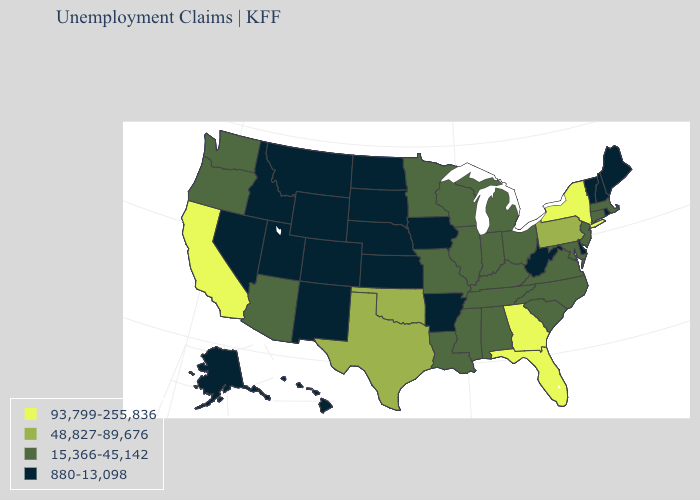What is the value of Virginia?
Give a very brief answer. 15,366-45,142. What is the highest value in states that border Arizona?
Give a very brief answer. 93,799-255,836. Which states have the lowest value in the Northeast?
Keep it brief. Maine, New Hampshire, Rhode Island, Vermont. What is the value of Iowa?
Concise answer only. 880-13,098. What is the value of Kansas?
Short answer required. 880-13,098. Which states hav the highest value in the South?
Concise answer only. Florida, Georgia. Does the map have missing data?
Short answer required. No. Name the states that have a value in the range 48,827-89,676?
Write a very short answer. Oklahoma, Pennsylvania, Texas. What is the value of Rhode Island?
Keep it brief. 880-13,098. Which states have the highest value in the USA?
Be succinct. California, Florida, Georgia, New York. What is the value of New York?
Quick response, please. 93,799-255,836. What is the value of Wisconsin?
Keep it brief. 15,366-45,142. Name the states that have a value in the range 880-13,098?
Answer briefly. Alaska, Arkansas, Colorado, Delaware, Hawaii, Idaho, Iowa, Kansas, Maine, Montana, Nebraska, Nevada, New Hampshire, New Mexico, North Dakota, Rhode Island, South Dakota, Utah, Vermont, West Virginia, Wyoming. Does California have the highest value in the West?
Be succinct. Yes. What is the highest value in the USA?
Short answer required. 93,799-255,836. 